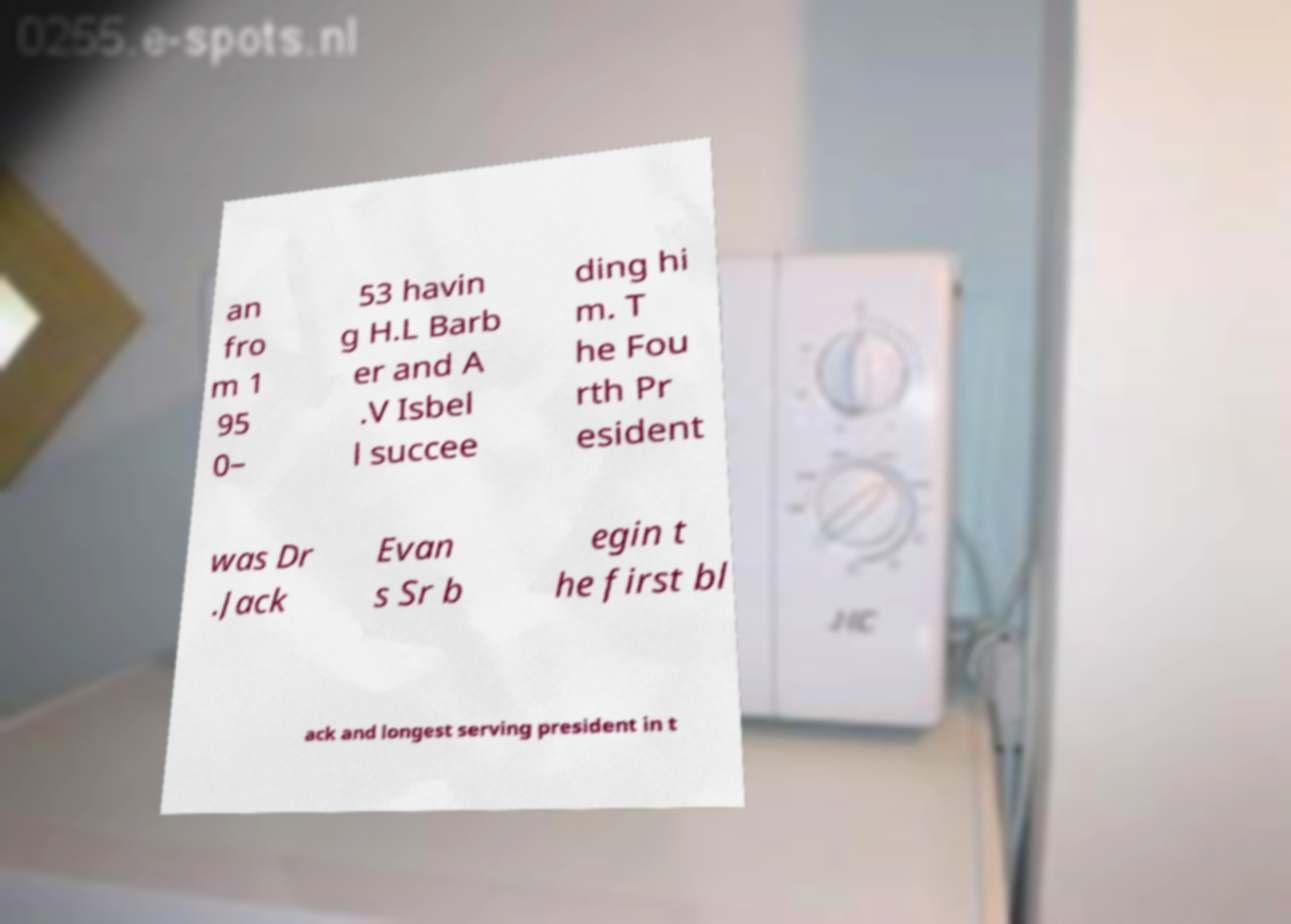There's text embedded in this image that I need extracted. Can you transcribe it verbatim? an fro m 1 95 0– 53 havin g H.L Barb er and A .V Isbel l succee ding hi m. T he Fou rth Pr esident was Dr .Jack Evan s Sr b egin t he first bl ack and longest serving president in t 